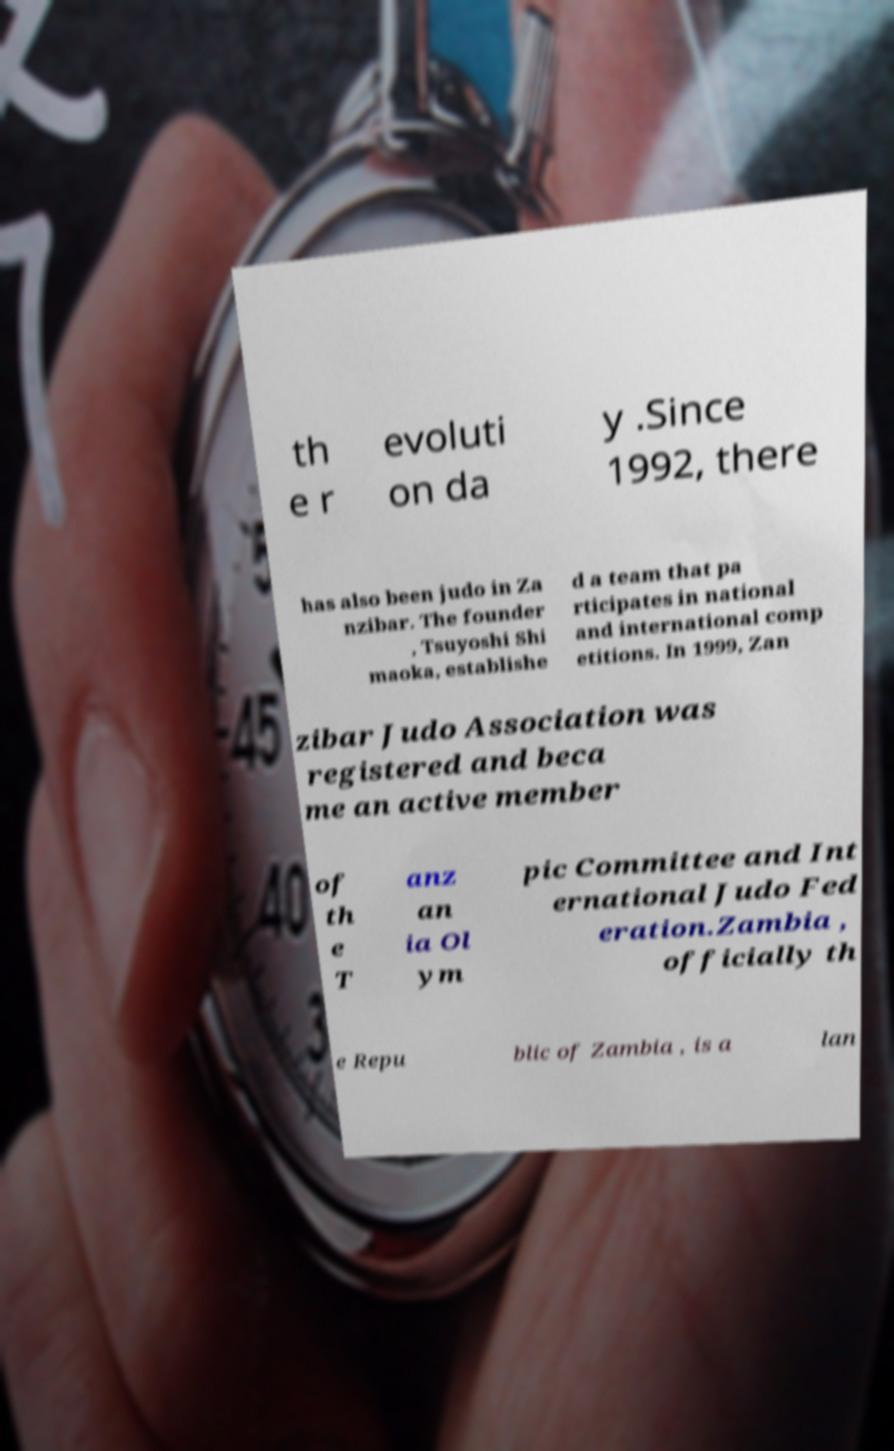There's text embedded in this image that I need extracted. Can you transcribe it verbatim? th e r evoluti on da y .Since 1992, there has also been judo in Za nzibar. The founder , Tsuyoshi Shi maoka, establishe d a team that pa rticipates in national and international comp etitions. In 1999, Zan zibar Judo Association was registered and beca me an active member of th e T anz an ia Ol ym pic Committee and Int ernational Judo Fed eration.Zambia , officially th e Repu blic of Zambia , is a lan 